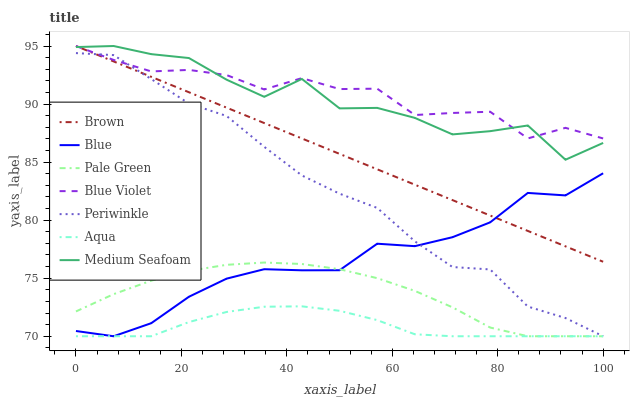Does Aqua have the minimum area under the curve?
Answer yes or no. Yes. Does Blue Violet have the maximum area under the curve?
Answer yes or no. Yes. Does Brown have the minimum area under the curve?
Answer yes or no. No. Does Brown have the maximum area under the curve?
Answer yes or no. No. Is Brown the smoothest?
Answer yes or no. Yes. Is Medium Seafoam the roughest?
Answer yes or no. Yes. Is Aqua the smoothest?
Answer yes or no. No. Is Aqua the roughest?
Answer yes or no. No. Does Blue have the lowest value?
Answer yes or no. Yes. Does Brown have the lowest value?
Answer yes or no. No. Does Blue Violet have the highest value?
Answer yes or no. Yes. Does Aqua have the highest value?
Answer yes or no. No. Is Pale Green less than Brown?
Answer yes or no. Yes. Is Brown greater than Pale Green?
Answer yes or no. Yes. Does Blue intersect Aqua?
Answer yes or no. Yes. Is Blue less than Aqua?
Answer yes or no. No. Is Blue greater than Aqua?
Answer yes or no. No. Does Pale Green intersect Brown?
Answer yes or no. No. 